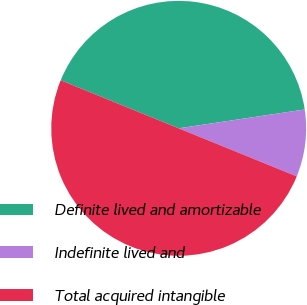<chart> <loc_0><loc_0><loc_500><loc_500><pie_chart><fcel>Definite lived and amortizable<fcel>Indefinite lived and<fcel>Total acquired intangible<nl><fcel>41.48%<fcel>8.52%<fcel>50.0%<nl></chart> 